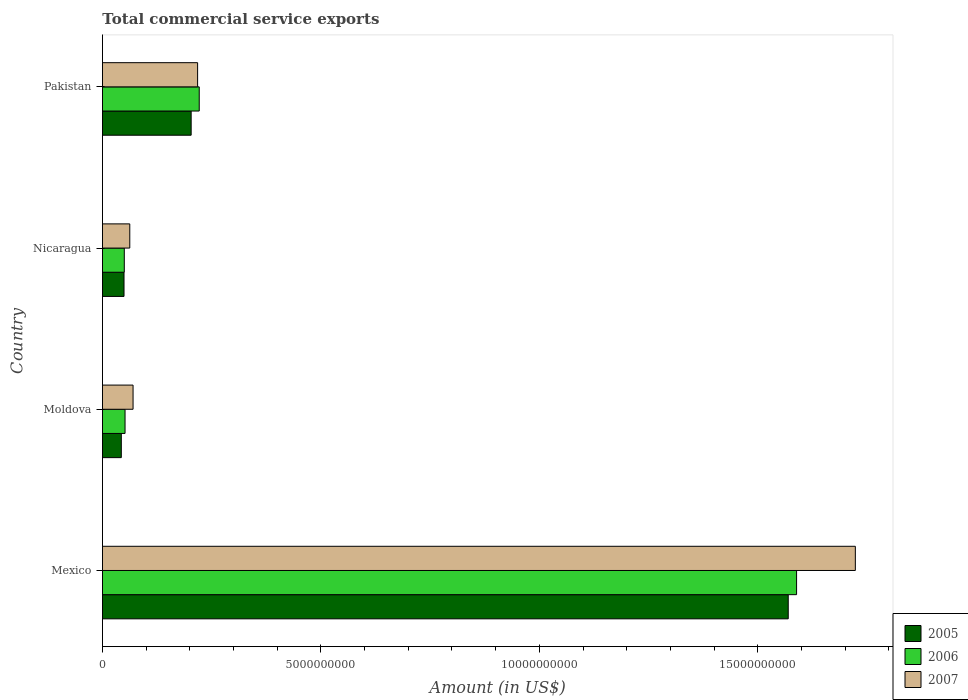How many different coloured bars are there?
Keep it short and to the point. 3. How many groups of bars are there?
Your response must be concise. 4. What is the label of the 4th group of bars from the top?
Offer a very short reply. Mexico. In how many cases, is the number of bars for a given country not equal to the number of legend labels?
Offer a terse response. 0. What is the total commercial service exports in 2006 in Moldova?
Give a very brief answer. 5.17e+08. Across all countries, what is the maximum total commercial service exports in 2007?
Offer a terse response. 1.72e+1. Across all countries, what is the minimum total commercial service exports in 2006?
Your answer should be compact. 5.00e+08. In which country was the total commercial service exports in 2007 minimum?
Keep it short and to the point. Nicaragua. What is the total total commercial service exports in 2006 in the graph?
Provide a succinct answer. 1.91e+1. What is the difference between the total commercial service exports in 2005 in Mexico and that in Moldova?
Your answer should be compact. 1.53e+1. What is the difference between the total commercial service exports in 2007 in Nicaragua and the total commercial service exports in 2005 in Mexico?
Give a very brief answer. -1.51e+1. What is the average total commercial service exports in 2005 per country?
Your response must be concise. 4.66e+09. What is the difference between the total commercial service exports in 2006 and total commercial service exports in 2007 in Moldova?
Make the answer very short. -1.84e+08. What is the ratio of the total commercial service exports in 2005 in Moldova to that in Nicaragua?
Your answer should be very brief. 0.87. Is the total commercial service exports in 2005 in Mexico less than that in Pakistan?
Provide a succinct answer. No. What is the difference between the highest and the second highest total commercial service exports in 2005?
Give a very brief answer. 1.37e+1. What is the difference between the highest and the lowest total commercial service exports in 2007?
Provide a succinct answer. 1.66e+1. In how many countries, is the total commercial service exports in 2006 greater than the average total commercial service exports in 2006 taken over all countries?
Give a very brief answer. 1. Is the sum of the total commercial service exports in 2007 in Moldova and Nicaragua greater than the maximum total commercial service exports in 2005 across all countries?
Your answer should be very brief. No. How many countries are there in the graph?
Offer a very short reply. 4. What is the difference between two consecutive major ticks on the X-axis?
Ensure brevity in your answer.  5.00e+09. Does the graph contain any zero values?
Give a very brief answer. No. Where does the legend appear in the graph?
Give a very brief answer. Bottom right. How many legend labels are there?
Give a very brief answer. 3. How are the legend labels stacked?
Your response must be concise. Vertical. What is the title of the graph?
Ensure brevity in your answer.  Total commercial service exports. What is the label or title of the X-axis?
Offer a terse response. Amount (in US$). What is the label or title of the Y-axis?
Offer a very short reply. Country. What is the Amount (in US$) of 2005 in Mexico?
Your response must be concise. 1.57e+1. What is the Amount (in US$) in 2006 in Mexico?
Your answer should be compact. 1.59e+1. What is the Amount (in US$) of 2007 in Mexico?
Give a very brief answer. 1.72e+1. What is the Amount (in US$) of 2005 in Moldova?
Your response must be concise. 4.31e+08. What is the Amount (in US$) of 2006 in Moldova?
Offer a terse response. 5.17e+08. What is the Amount (in US$) of 2007 in Moldova?
Your answer should be very brief. 7.00e+08. What is the Amount (in US$) of 2005 in Nicaragua?
Your answer should be compact. 4.93e+08. What is the Amount (in US$) of 2006 in Nicaragua?
Provide a short and direct response. 5.00e+08. What is the Amount (in US$) of 2007 in Nicaragua?
Your answer should be very brief. 6.25e+08. What is the Amount (in US$) in 2005 in Pakistan?
Offer a terse response. 2.03e+09. What is the Amount (in US$) of 2006 in Pakistan?
Provide a short and direct response. 2.22e+09. What is the Amount (in US$) in 2007 in Pakistan?
Make the answer very short. 2.18e+09. Across all countries, what is the maximum Amount (in US$) in 2005?
Your response must be concise. 1.57e+1. Across all countries, what is the maximum Amount (in US$) in 2006?
Make the answer very short. 1.59e+1. Across all countries, what is the maximum Amount (in US$) in 2007?
Offer a very short reply. 1.72e+1. Across all countries, what is the minimum Amount (in US$) in 2005?
Offer a very short reply. 4.31e+08. Across all countries, what is the minimum Amount (in US$) of 2006?
Your answer should be compact. 5.00e+08. Across all countries, what is the minimum Amount (in US$) in 2007?
Your answer should be very brief. 6.25e+08. What is the total Amount (in US$) of 2005 in the graph?
Offer a terse response. 1.87e+1. What is the total Amount (in US$) in 2006 in the graph?
Keep it short and to the point. 1.91e+1. What is the total Amount (in US$) in 2007 in the graph?
Your answer should be very brief. 2.07e+1. What is the difference between the Amount (in US$) of 2005 in Mexico and that in Moldova?
Give a very brief answer. 1.53e+1. What is the difference between the Amount (in US$) of 2006 in Mexico and that in Moldova?
Make the answer very short. 1.54e+1. What is the difference between the Amount (in US$) in 2007 in Mexico and that in Moldova?
Offer a terse response. 1.65e+1. What is the difference between the Amount (in US$) in 2005 in Mexico and that in Nicaragua?
Offer a very short reply. 1.52e+1. What is the difference between the Amount (in US$) in 2006 in Mexico and that in Nicaragua?
Your response must be concise. 1.54e+1. What is the difference between the Amount (in US$) in 2007 in Mexico and that in Nicaragua?
Your response must be concise. 1.66e+1. What is the difference between the Amount (in US$) in 2005 in Mexico and that in Pakistan?
Your response must be concise. 1.37e+1. What is the difference between the Amount (in US$) in 2006 in Mexico and that in Pakistan?
Offer a very short reply. 1.37e+1. What is the difference between the Amount (in US$) of 2007 in Mexico and that in Pakistan?
Offer a terse response. 1.51e+1. What is the difference between the Amount (in US$) of 2005 in Moldova and that in Nicaragua?
Provide a short and direct response. -6.21e+07. What is the difference between the Amount (in US$) of 2006 in Moldova and that in Nicaragua?
Offer a terse response. 1.72e+07. What is the difference between the Amount (in US$) of 2007 in Moldova and that in Nicaragua?
Provide a succinct answer. 7.50e+07. What is the difference between the Amount (in US$) in 2005 in Moldova and that in Pakistan?
Provide a succinct answer. -1.60e+09. What is the difference between the Amount (in US$) in 2006 in Moldova and that in Pakistan?
Your response must be concise. -1.70e+09. What is the difference between the Amount (in US$) of 2007 in Moldova and that in Pakistan?
Make the answer very short. -1.48e+09. What is the difference between the Amount (in US$) of 2005 in Nicaragua and that in Pakistan?
Ensure brevity in your answer.  -1.54e+09. What is the difference between the Amount (in US$) of 2006 in Nicaragua and that in Pakistan?
Give a very brief answer. -1.72e+09. What is the difference between the Amount (in US$) of 2007 in Nicaragua and that in Pakistan?
Make the answer very short. -1.55e+09. What is the difference between the Amount (in US$) of 2005 in Mexico and the Amount (in US$) of 2006 in Moldova?
Make the answer very short. 1.52e+1. What is the difference between the Amount (in US$) of 2005 in Mexico and the Amount (in US$) of 2007 in Moldova?
Provide a succinct answer. 1.50e+1. What is the difference between the Amount (in US$) in 2006 in Mexico and the Amount (in US$) in 2007 in Moldova?
Your answer should be very brief. 1.52e+1. What is the difference between the Amount (in US$) of 2005 in Mexico and the Amount (in US$) of 2006 in Nicaragua?
Make the answer very short. 1.52e+1. What is the difference between the Amount (in US$) in 2005 in Mexico and the Amount (in US$) in 2007 in Nicaragua?
Make the answer very short. 1.51e+1. What is the difference between the Amount (in US$) in 2006 in Mexico and the Amount (in US$) in 2007 in Nicaragua?
Offer a terse response. 1.53e+1. What is the difference between the Amount (in US$) in 2005 in Mexico and the Amount (in US$) in 2006 in Pakistan?
Your answer should be very brief. 1.35e+1. What is the difference between the Amount (in US$) in 2005 in Mexico and the Amount (in US$) in 2007 in Pakistan?
Provide a succinct answer. 1.35e+1. What is the difference between the Amount (in US$) in 2006 in Mexico and the Amount (in US$) in 2007 in Pakistan?
Your response must be concise. 1.37e+1. What is the difference between the Amount (in US$) of 2005 in Moldova and the Amount (in US$) of 2006 in Nicaragua?
Provide a short and direct response. -6.83e+07. What is the difference between the Amount (in US$) in 2005 in Moldova and the Amount (in US$) in 2007 in Nicaragua?
Ensure brevity in your answer.  -1.94e+08. What is the difference between the Amount (in US$) in 2006 in Moldova and the Amount (in US$) in 2007 in Nicaragua?
Provide a short and direct response. -1.09e+08. What is the difference between the Amount (in US$) in 2005 in Moldova and the Amount (in US$) in 2006 in Pakistan?
Offer a terse response. -1.78e+09. What is the difference between the Amount (in US$) of 2005 in Moldova and the Amount (in US$) of 2007 in Pakistan?
Your answer should be compact. -1.75e+09. What is the difference between the Amount (in US$) in 2006 in Moldova and the Amount (in US$) in 2007 in Pakistan?
Give a very brief answer. -1.66e+09. What is the difference between the Amount (in US$) of 2005 in Nicaragua and the Amount (in US$) of 2006 in Pakistan?
Offer a very short reply. -1.72e+09. What is the difference between the Amount (in US$) of 2005 in Nicaragua and the Amount (in US$) of 2007 in Pakistan?
Your answer should be very brief. -1.68e+09. What is the difference between the Amount (in US$) of 2006 in Nicaragua and the Amount (in US$) of 2007 in Pakistan?
Offer a terse response. -1.68e+09. What is the average Amount (in US$) in 2005 per country?
Provide a short and direct response. 4.66e+09. What is the average Amount (in US$) in 2006 per country?
Your response must be concise. 4.78e+09. What is the average Amount (in US$) of 2007 per country?
Your response must be concise. 5.18e+09. What is the difference between the Amount (in US$) in 2005 and Amount (in US$) in 2006 in Mexico?
Ensure brevity in your answer.  -1.91e+08. What is the difference between the Amount (in US$) of 2005 and Amount (in US$) of 2007 in Mexico?
Provide a succinct answer. -1.54e+09. What is the difference between the Amount (in US$) of 2006 and Amount (in US$) of 2007 in Mexico?
Your answer should be compact. -1.35e+09. What is the difference between the Amount (in US$) in 2005 and Amount (in US$) in 2006 in Moldova?
Make the answer very short. -8.55e+07. What is the difference between the Amount (in US$) in 2005 and Amount (in US$) in 2007 in Moldova?
Offer a terse response. -2.69e+08. What is the difference between the Amount (in US$) in 2006 and Amount (in US$) in 2007 in Moldova?
Provide a short and direct response. -1.84e+08. What is the difference between the Amount (in US$) in 2005 and Amount (in US$) in 2006 in Nicaragua?
Give a very brief answer. -6.20e+06. What is the difference between the Amount (in US$) of 2005 and Amount (in US$) of 2007 in Nicaragua?
Your answer should be very brief. -1.32e+08. What is the difference between the Amount (in US$) in 2006 and Amount (in US$) in 2007 in Nicaragua?
Offer a very short reply. -1.26e+08. What is the difference between the Amount (in US$) of 2005 and Amount (in US$) of 2006 in Pakistan?
Keep it short and to the point. -1.85e+08. What is the difference between the Amount (in US$) in 2005 and Amount (in US$) in 2007 in Pakistan?
Your answer should be compact. -1.48e+08. What is the difference between the Amount (in US$) in 2006 and Amount (in US$) in 2007 in Pakistan?
Offer a very short reply. 3.73e+07. What is the ratio of the Amount (in US$) of 2005 in Mexico to that in Moldova?
Your response must be concise. 36.39. What is the ratio of the Amount (in US$) in 2006 in Mexico to that in Moldova?
Your answer should be very brief. 30.74. What is the ratio of the Amount (in US$) of 2007 in Mexico to that in Moldova?
Your answer should be compact. 24.61. What is the ratio of the Amount (in US$) in 2005 in Mexico to that in Nicaragua?
Provide a short and direct response. 31.81. What is the ratio of the Amount (in US$) in 2006 in Mexico to that in Nicaragua?
Your answer should be compact. 31.8. What is the ratio of the Amount (in US$) in 2007 in Mexico to that in Nicaragua?
Make the answer very short. 27.56. What is the ratio of the Amount (in US$) in 2005 in Mexico to that in Pakistan?
Your answer should be compact. 7.73. What is the ratio of the Amount (in US$) in 2006 in Mexico to that in Pakistan?
Offer a very short reply. 7.17. What is the ratio of the Amount (in US$) in 2007 in Mexico to that in Pakistan?
Give a very brief answer. 7.91. What is the ratio of the Amount (in US$) in 2005 in Moldova to that in Nicaragua?
Your answer should be compact. 0.87. What is the ratio of the Amount (in US$) of 2006 in Moldova to that in Nicaragua?
Keep it short and to the point. 1.03. What is the ratio of the Amount (in US$) of 2007 in Moldova to that in Nicaragua?
Offer a very short reply. 1.12. What is the ratio of the Amount (in US$) of 2005 in Moldova to that in Pakistan?
Keep it short and to the point. 0.21. What is the ratio of the Amount (in US$) of 2006 in Moldova to that in Pakistan?
Provide a short and direct response. 0.23. What is the ratio of the Amount (in US$) in 2007 in Moldova to that in Pakistan?
Make the answer very short. 0.32. What is the ratio of the Amount (in US$) in 2005 in Nicaragua to that in Pakistan?
Keep it short and to the point. 0.24. What is the ratio of the Amount (in US$) of 2006 in Nicaragua to that in Pakistan?
Offer a very short reply. 0.23. What is the ratio of the Amount (in US$) in 2007 in Nicaragua to that in Pakistan?
Provide a short and direct response. 0.29. What is the difference between the highest and the second highest Amount (in US$) in 2005?
Provide a succinct answer. 1.37e+1. What is the difference between the highest and the second highest Amount (in US$) in 2006?
Give a very brief answer. 1.37e+1. What is the difference between the highest and the second highest Amount (in US$) of 2007?
Your response must be concise. 1.51e+1. What is the difference between the highest and the lowest Amount (in US$) of 2005?
Your response must be concise. 1.53e+1. What is the difference between the highest and the lowest Amount (in US$) of 2006?
Your answer should be compact. 1.54e+1. What is the difference between the highest and the lowest Amount (in US$) in 2007?
Your answer should be very brief. 1.66e+1. 